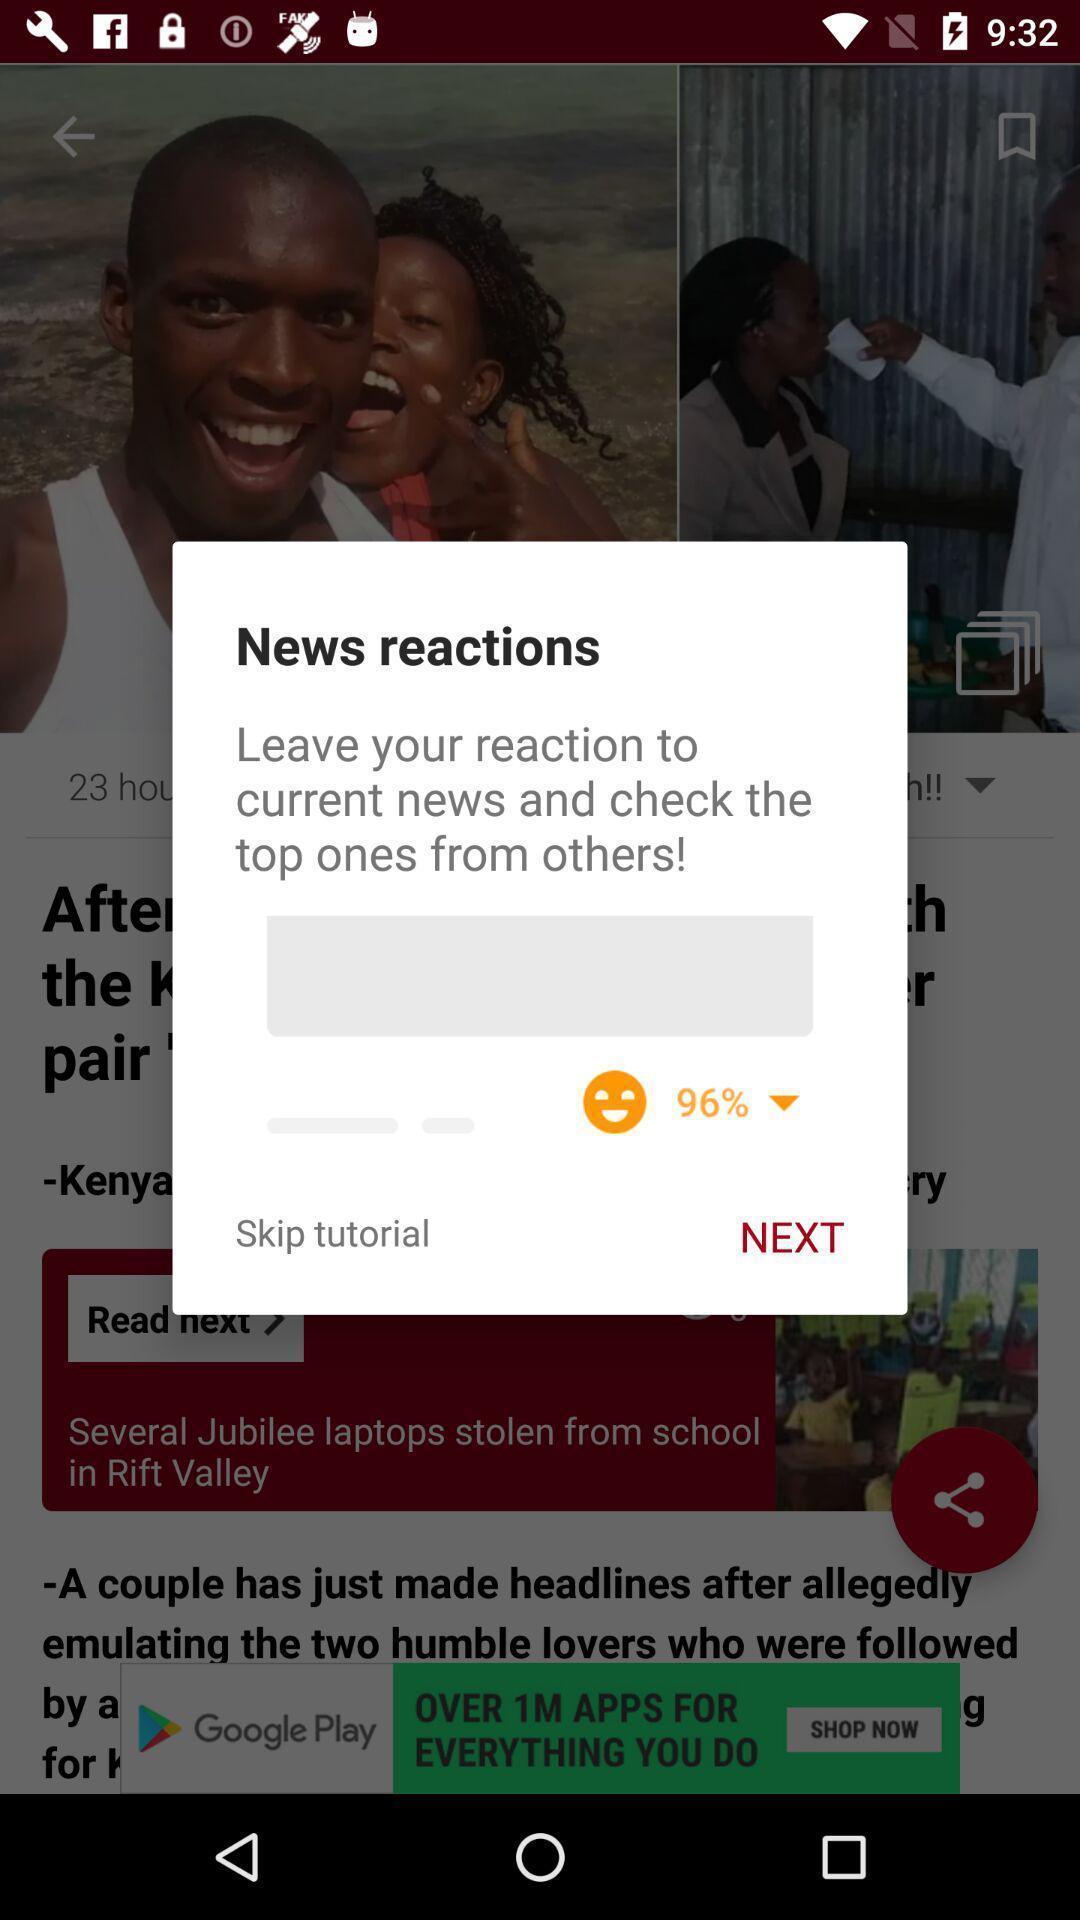Summarize the main components in this picture. Popup to not down your reaction on news. 